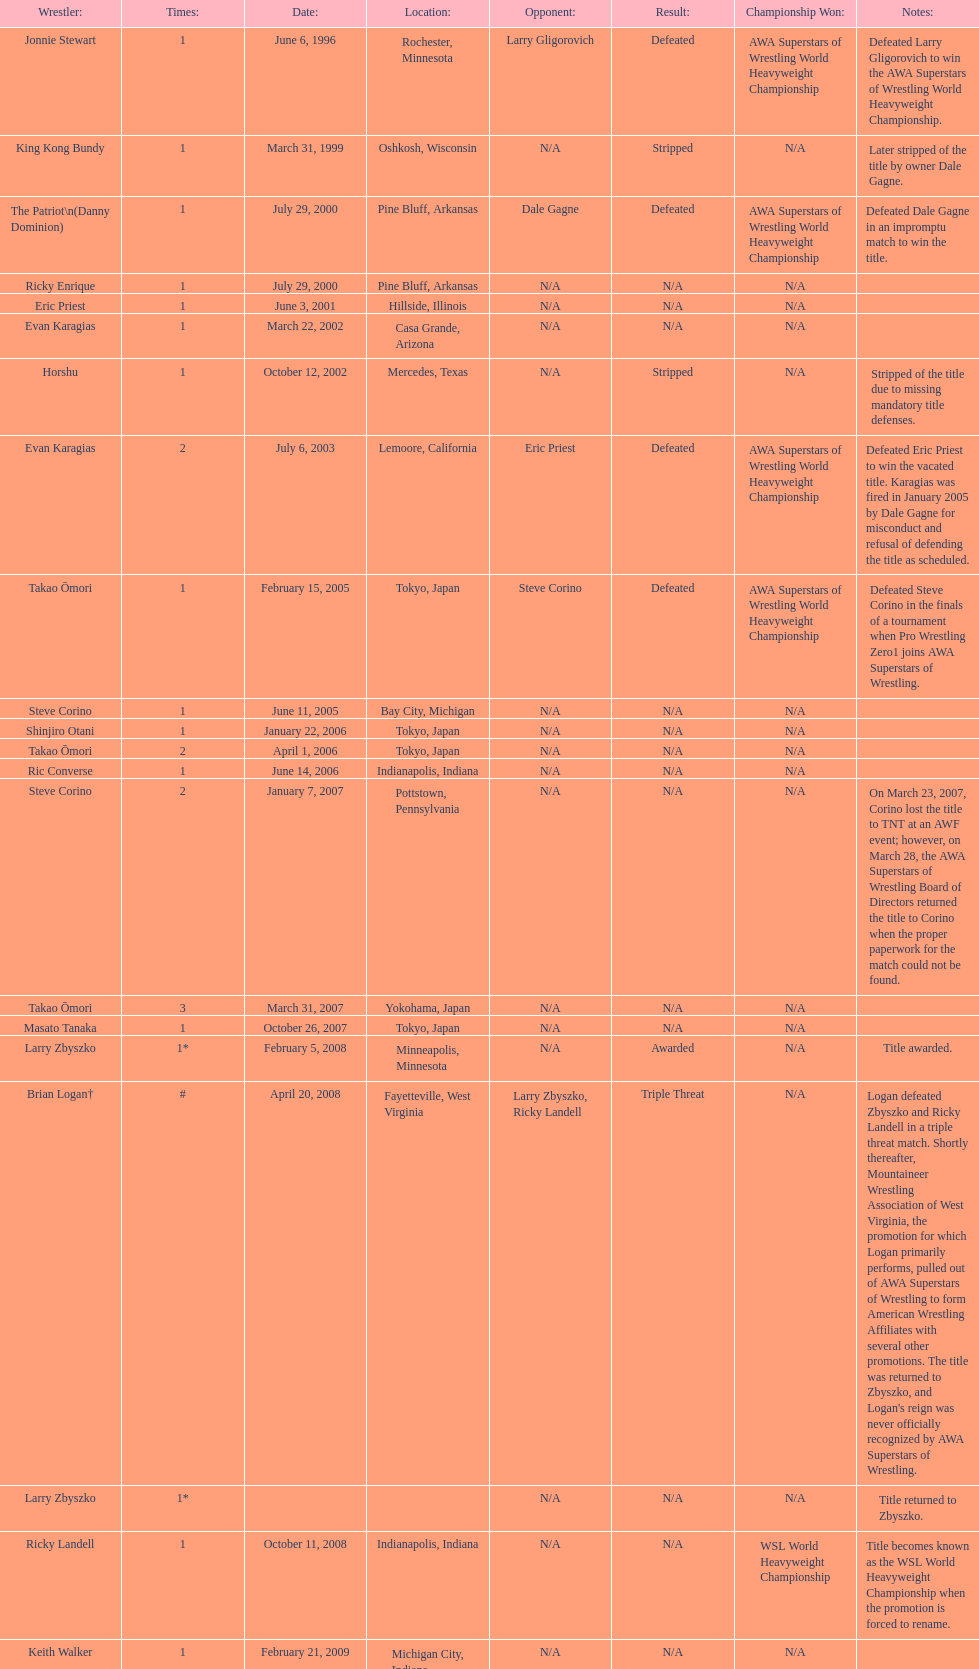Who is listed before keith walker? Ricky Landell. 